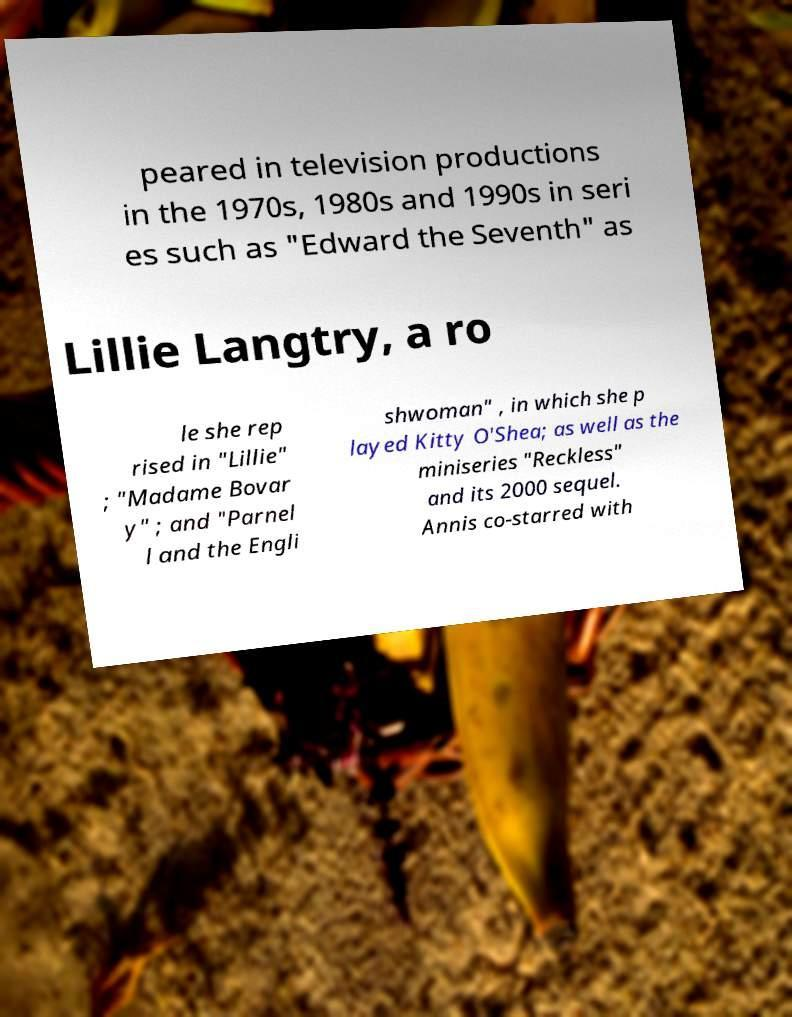Can you accurately transcribe the text from the provided image for me? peared in television productions in the 1970s, 1980s and 1990s in seri es such as "Edward the Seventh" as Lillie Langtry, a ro le she rep rised in "Lillie" ; "Madame Bovar y" ; and "Parnel l and the Engli shwoman" , in which she p layed Kitty O'Shea; as well as the miniseries "Reckless" and its 2000 sequel. Annis co-starred with 